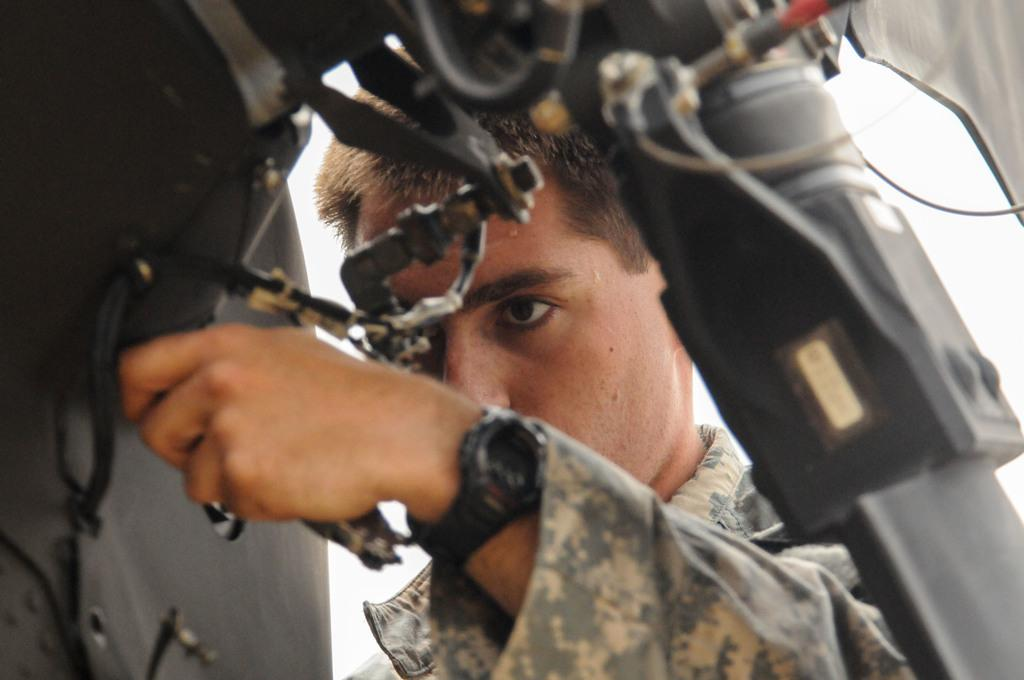What is present in the image? There is a person in the image. What is the person doing in the image? The person is holding an object. What type of animal can be seen in the image? There is no animal present in the image; it features a person holding an object. What shape is the moon in the image? There is no moon present in the image. 